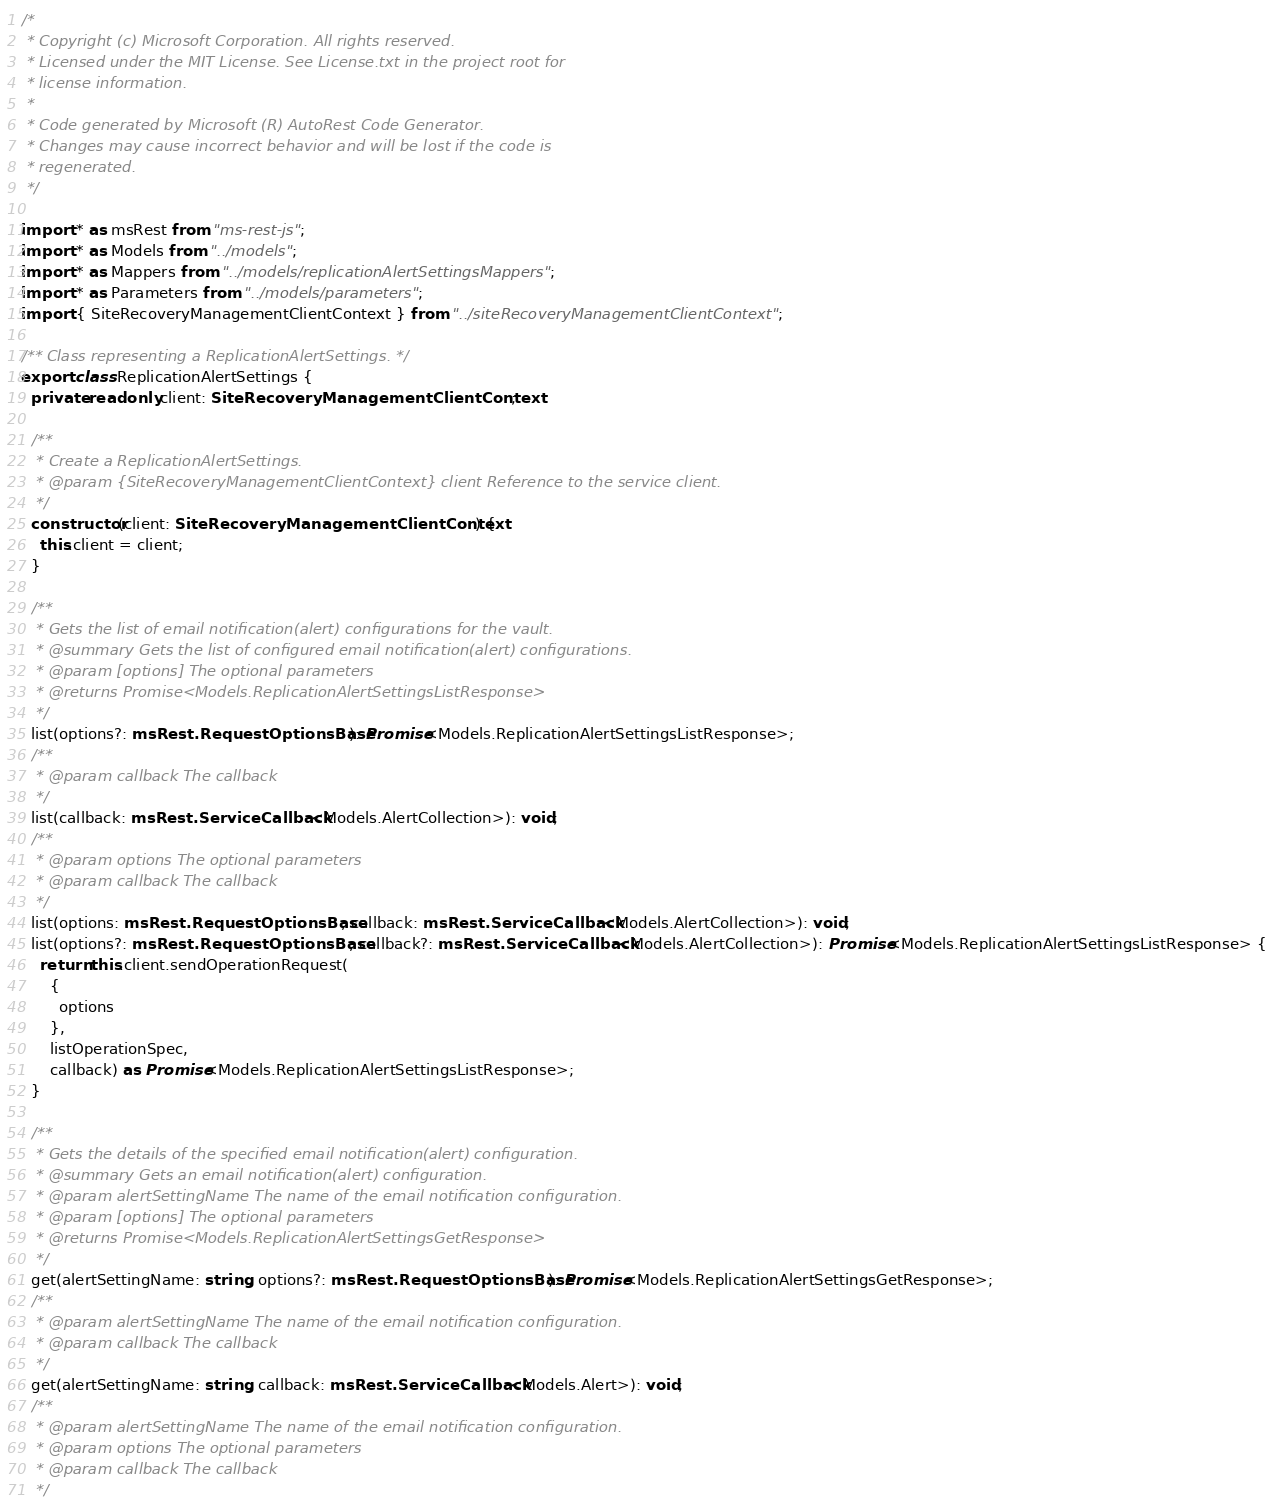<code> <loc_0><loc_0><loc_500><loc_500><_TypeScript_>/*
 * Copyright (c) Microsoft Corporation. All rights reserved.
 * Licensed under the MIT License. See License.txt in the project root for
 * license information.
 *
 * Code generated by Microsoft (R) AutoRest Code Generator.
 * Changes may cause incorrect behavior and will be lost if the code is
 * regenerated.
 */

import * as msRest from "ms-rest-js";
import * as Models from "../models";
import * as Mappers from "../models/replicationAlertSettingsMappers";
import * as Parameters from "../models/parameters";
import { SiteRecoveryManagementClientContext } from "../siteRecoveryManagementClientContext";

/** Class representing a ReplicationAlertSettings. */
export class ReplicationAlertSettings {
  private readonly client: SiteRecoveryManagementClientContext;

  /**
   * Create a ReplicationAlertSettings.
   * @param {SiteRecoveryManagementClientContext} client Reference to the service client.
   */
  constructor(client: SiteRecoveryManagementClientContext) {
    this.client = client;
  }

  /**
   * Gets the list of email notification(alert) configurations for the vault.
   * @summary Gets the list of configured email notification(alert) configurations.
   * @param [options] The optional parameters
   * @returns Promise<Models.ReplicationAlertSettingsListResponse>
   */
  list(options?: msRest.RequestOptionsBase): Promise<Models.ReplicationAlertSettingsListResponse>;
  /**
   * @param callback The callback
   */
  list(callback: msRest.ServiceCallback<Models.AlertCollection>): void;
  /**
   * @param options The optional parameters
   * @param callback The callback
   */
  list(options: msRest.RequestOptionsBase, callback: msRest.ServiceCallback<Models.AlertCollection>): void;
  list(options?: msRest.RequestOptionsBase, callback?: msRest.ServiceCallback<Models.AlertCollection>): Promise<Models.ReplicationAlertSettingsListResponse> {
    return this.client.sendOperationRequest(
      {
        options
      },
      listOperationSpec,
      callback) as Promise<Models.ReplicationAlertSettingsListResponse>;
  }

  /**
   * Gets the details of the specified email notification(alert) configuration.
   * @summary Gets an email notification(alert) configuration.
   * @param alertSettingName The name of the email notification configuration.
   * @param [options] The optional parameters
   * @returns Promise<Models.ReplicationAlertSettingsGetResponse>
   */
  get(alertSettingName: string, options?: msRest.RequestOptionsBase): Promise<Models.ReplicationAlertSettingsGetResponse>;
  /**
   * @param alertSettingName The name of the email notification configuration.
   * @param callback The callback
   */
  get(alertSettingName: string, callback: msRest.ServiceCallback<Models.Alert>): void;
  /**
   * @param alertSettingName The name of the email notification configuration.
   * @param options The optional parameters
   * @param callback The callback
   */</code> 